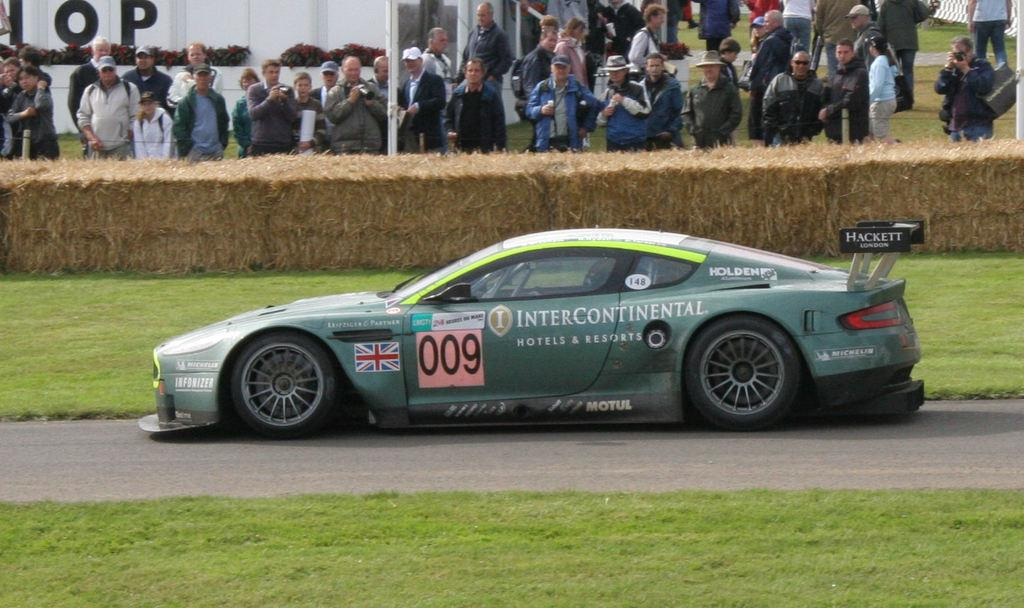What is the main subject in the center of the image? There is a sports car in the center of the image. What type of terrain is visible at the bottom side of the image? There is grassland at the bottom side of the image. What can be seen in the top side of the image? There are people, plants, a pole, and bales in the top side of the image. What type of insurance policy is being discussed by the people in the image? There is no indication in the image that the people are discussing any insurance policies. 